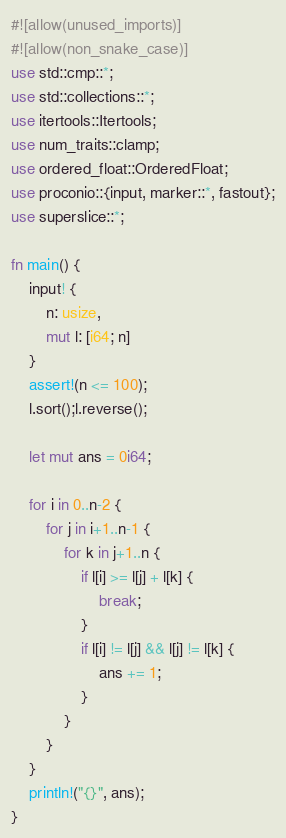<code> <loc_0><loc_0><loc_500><loc_500><_Rust_>#![allow(unused_imports)]
#![allow(non_snake_case)]
use std::cmp::*;
use std::collections::*;
use itertools::Itertools;
use num_traits::clamp;
use ordered_float::OrderedFloat;
use proconio::{input, marker::*, fastout};
use superslice::*;

fn main() {
    input! {
        n: usize,
        mut l: [i64; n]
    }
    assert!(n <= 100);
    l.sort();l.reverse();
    
    let mut ans = 0i64;

    for i in 0..n-2 {
        for j in i+1..n-1 {
            for k in j+1..n {
                if l[i] >= l[j] + l[k] {
                    break;
                }
                if l[i] != l[j] && l[j] != l[k] {
                    ans += 1;
                }
            }
        }
    }
    println!("{}", ans);
}
</code> 